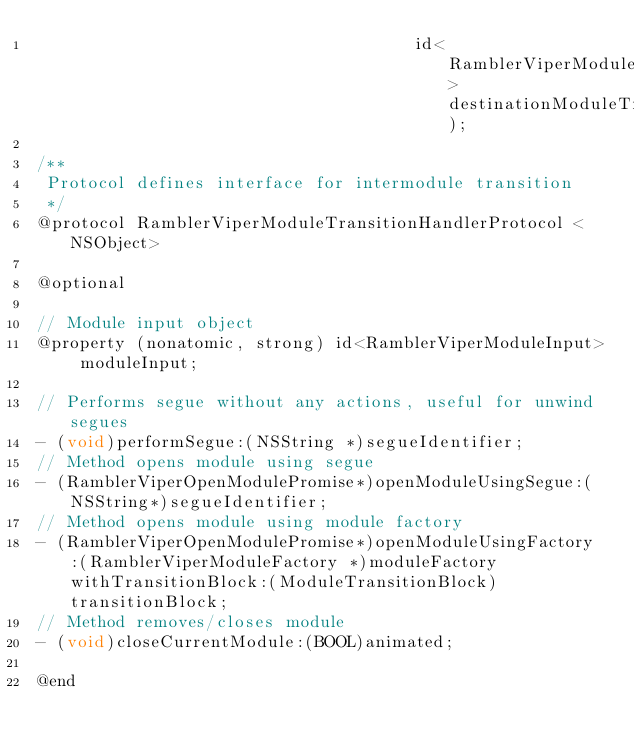Convert code to text. <code><loc_0><loc_0><loc_500><loc_500><_C_>                                      id<RamblerViperModuleTransitionHandlerProtocol> destinationModuleTransitionHandler);

/**
 Protocol defines interface for intermodule transition
 */
@protocol RamblerViperModuleTransitionHandlerProtocol <NSObject>

@optional

// Module input object
@property (nonatomic, strong) id<RamblerViperModuleInput> moduleInput;

// Performs segue without any actions, useful for unwind segues
- (void)performSegue:(NSString *)segueIdentifier;
// Method opens module using segue
- (RamblerViperOpenModulePromise*)openModuleUsingSegue:(NSString*)segueIdentifier;
// Method opens module using module factory
- (RamblerViperOpenModulePromise*)openModuleUsingFactory:(RamblerViperModuleFactory *)moduleFactory withTransitionBlock:(ModuleTransitionBlock)transitionBlock;
// Method removes/closes module
- (void)closeCurrentModule:(BOOL)animated;

@end
</code> 